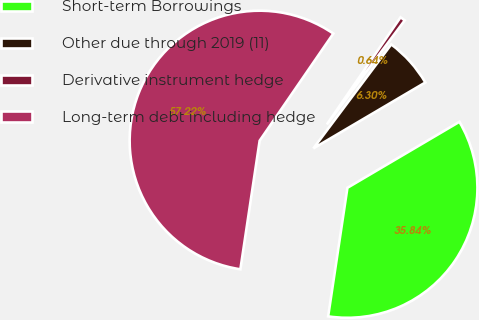Convert chart. <chart><loc_0><loc_0><loc_500><loc_500><pie_chart><fcel>Short-term Borrowings<fcel>Other due through 2019 (11)<fcel>Derivative instrument hedge<fcel>Long-term debt including hedge<nl><fcel>35.84%<fcel>6.3%<fcel>0.64%<fcel>57.22%<nl></chart> 